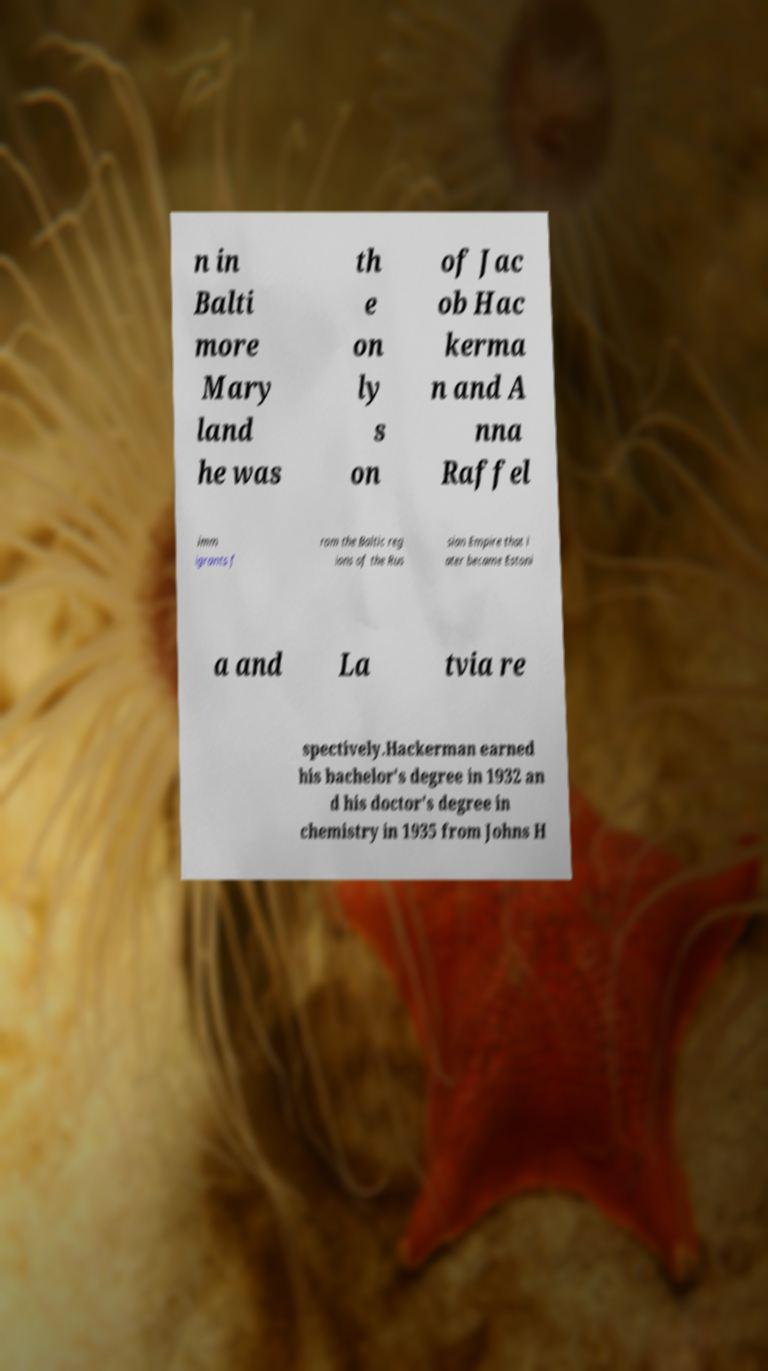For documentation purposes, I need the text within this image transcribed. Could you provide that? n in Balti more Mary land he was th e on ly s on of Jac ob Hac kerma n and A nna Raffel imm igrants f rom the Baltic reg ions of the Rus sian Empire that l ater became Estoni a and La tvia re spectively.Hackerman earned his bachelor's degree in 1932 an d his doctor's degree in chemistry in 1935 from Johns H 